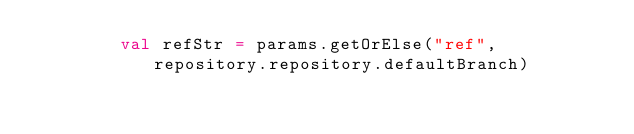<code> <loc_0><loc_0><loc_500><loc_500><_Scala_>        val refStr = params.getOrElse("ref", repository.repository.defaultBranch)</code> 